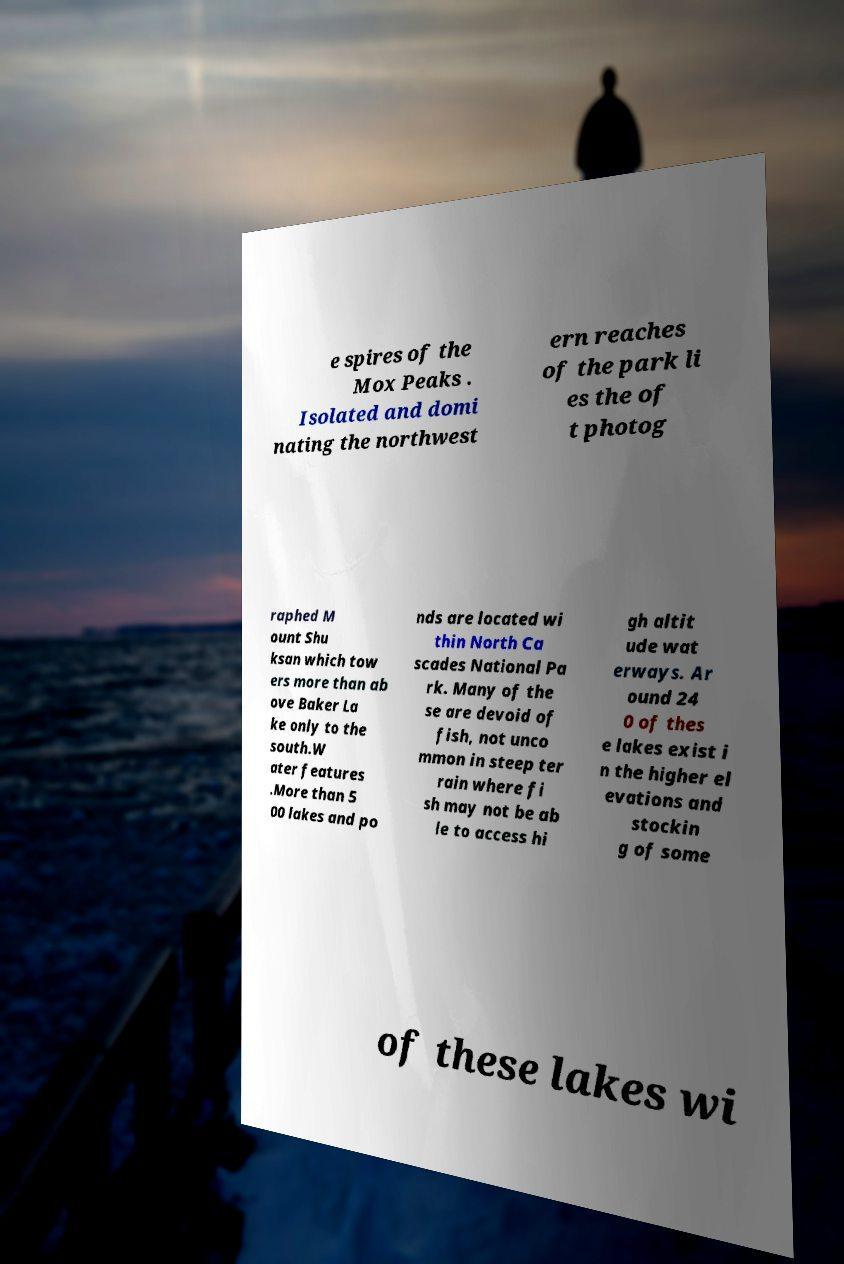Can you read and provide the text displayed in the image?This photo seems to have some interesting text. Can you extract and type it out for me? e spires of the Mox Peaks . Isolated and domi nating the northwest ern reaches of the park li es the of t photog raphed M ount Shu ksan which tow ers more than ab ove Baker La ke only to the south.W ater features .More than 5 00 lakes and po nds are located wi thin North Ca scades National Pa rk. Many of the se are devoid of fish, not unco mmon in steep ter rain where fi sh may not be ab le to access hi gh altit ude wat erways. Ar ound 24 0 of thes e lakes exist i n the higher el evations and stockin g of some of these lakes wi 